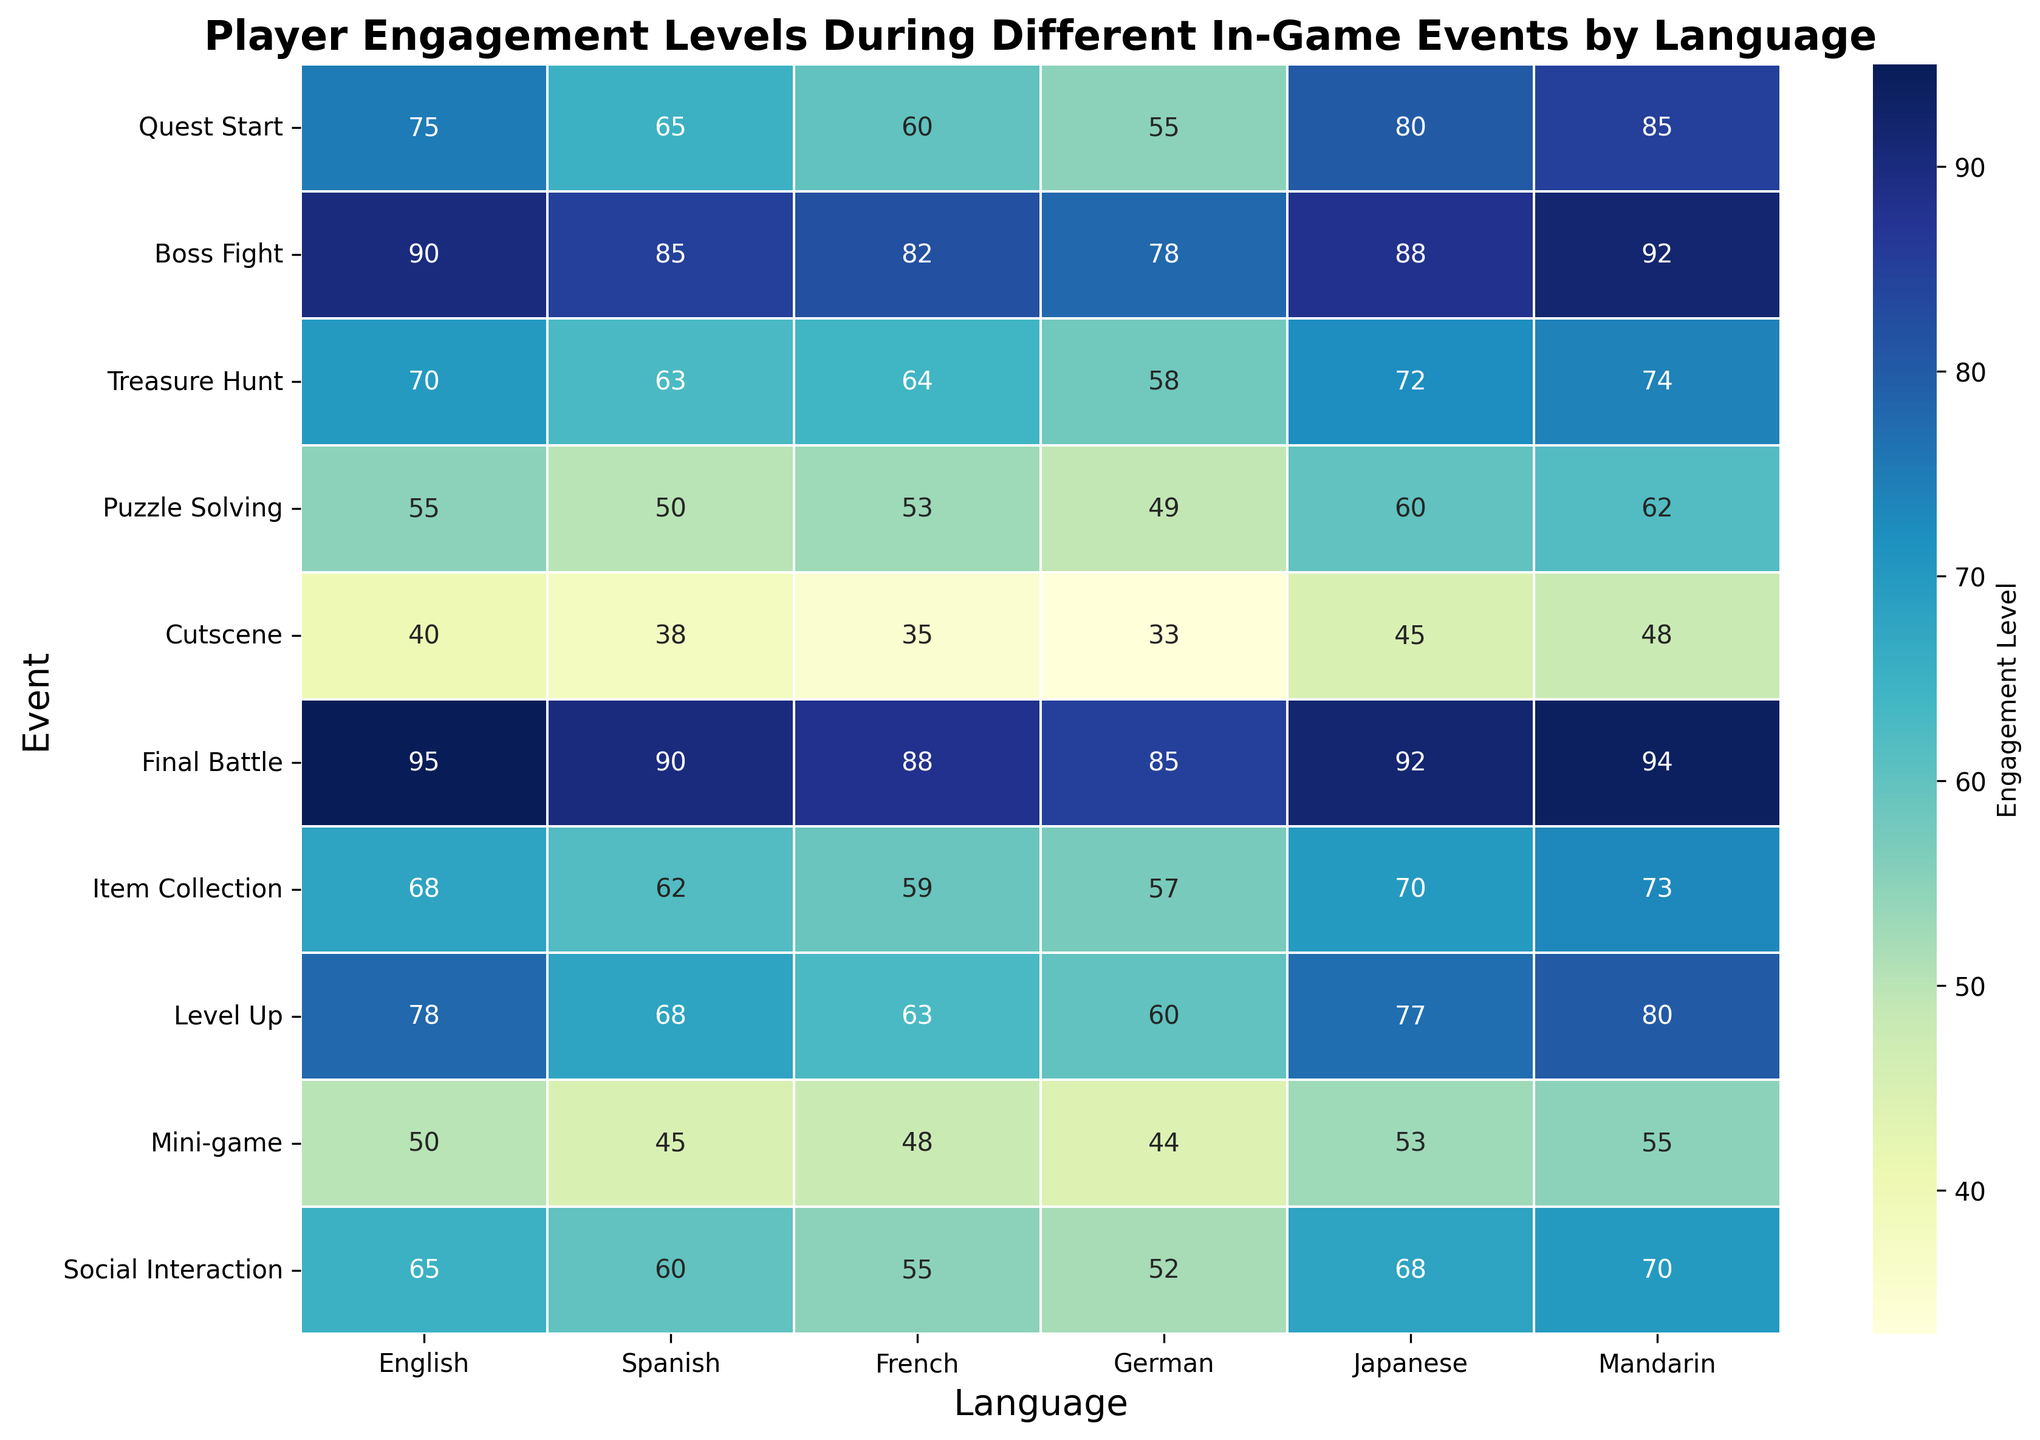What event has the highest player engagement level for the French language? Locate the column labeled "French" and look for the highest value. The highest engagement level for French is 88, which corresponds to the event "Final Battle".
Answer: Final Battle Which event has the lowest player engagement level in Mandarin? Locate the column labeled "Mandarin" and identify the lowest value. The lowest engagement level for Mandarin is 48, which corresponds to the "Cutscene" event.
Answer: Cutscene How much higher is player engagement in Japanese during the "Boss Fight" event compared to the "Cutscene" event? Find the values for Japanese during "Boss Fight" (88) and "Cutscene" (45), then subtract to find the difference. 88 - 45 equals 40.
Answer: 40 What is the average player engagement level for German during the "Social Interaction" and "Puzzle Solving" events? Look for German's engagement during "Social Interaction" (52) and "Puzzle Solving" (49). Add these values together: 52 + 49 = 101. Then divide by 2, 101/2 = 50.5.
Answer: 50.5 Which language shows the highest engagement for the "Level Up" event, and what is the value? Locate the row for "Level Up" and look for the highest value across all languages. The highest value in the "Level Up" row is 80 for Mandarin.
Answer: Mandarin, 80 Compare the engagement levels for English and Spanish during "Quest Start". Which language has higher engagement and by how much? Locate the values for English (75) and Spanish (65) in the "Quest Start" row. Subtract the Spanish value from the English value, 75 - 65 = 10.
Answer: English by 10 How does the engagement in "Item Collection" for English compare with French? Find the values in the "Item Collection" row for English (68) and French (59). English has a higher engagement level than French.
Answer: English is higher What is the second highest engagement level for Spanish, and during which event does it occur? Locate the column for Spanish and identify the second highest value after 90. The second highest engagement is 85, which occurs during "Boss Fight".
Answer: 85, Boss Fight Which event has the most similar engagement levels across all languages? Review each row for consistency in the values across different languages. "Item Collection" shows relatively similar engagement levels of 68, 62, 59, 57, 70, 73.
Answer: Item Collection 